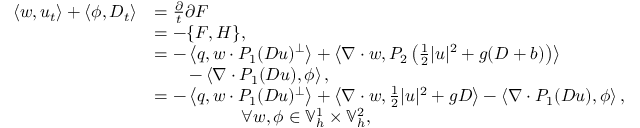<formula> <loc_0><loc_0><loc_500><loc_500>\begin{array} { r l } { \left \langle w , u _ { t } \right \rangle + \left \langle \phi , D _ { t } \right \rangle } & { = \frac { \partial } { t } { \partial F } } \\ & { = - \{ F , H \} , } \\ & { = - \left \langle q , w \cdot P _ { 1 } ( D u ) ^ { \perp } \right \rangle + \left \langle \nabla \cdot w , P _ { 2 } \left ( \frac { 1 } { 2 } | u | ^ { 2 } + g ( D + b ) \right ) \right \rangle } \\ & { \quad - \left \langle \nabla \cdot P _ { 1 } ( D u ) , \phi \right \rangle , } \\ & { = - \left \langle q , w \cdot P _ { 1 } ( D u ) ^ { \perp } \right \rangle + \left \langle \nabla \cdot w , \frac { 1 } { 2 } | u | ^ { 2 } + g D \right \rangle - \left \langle \nabla \cdot P _ { 1 } ( D u ) , \phi \right \rangle , } \\ & { \quad \forall w , \phi \in \mathbb { V } _ { h } ^ { 1 } \times \mathbb { V } _ { h } ^ { 2 } , } \end{array}</formula> 